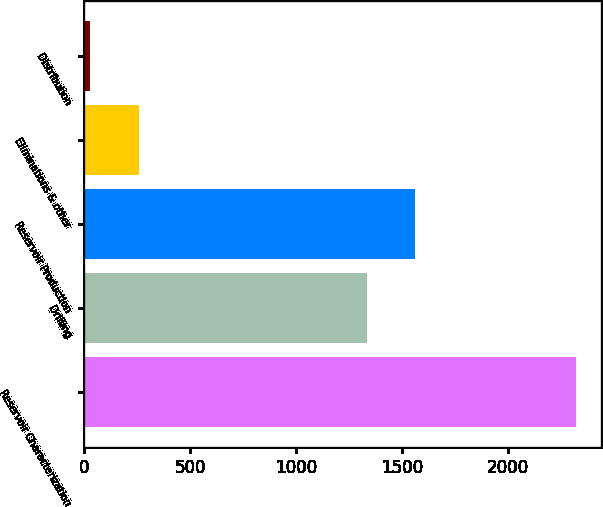Convert chart. <chart><loc_0><loc_0><loc_500><loc_500><bar_chart><fcel>Reservoir Characterization<fcel>Drilling<fcel>Reservoir Production<fcel>Eliminations & other<fcel>Distribution<nl><fcel>2321<fcel>1334<fcel>1563.2<fcel>258.2<fcel>29<nl></chart> 